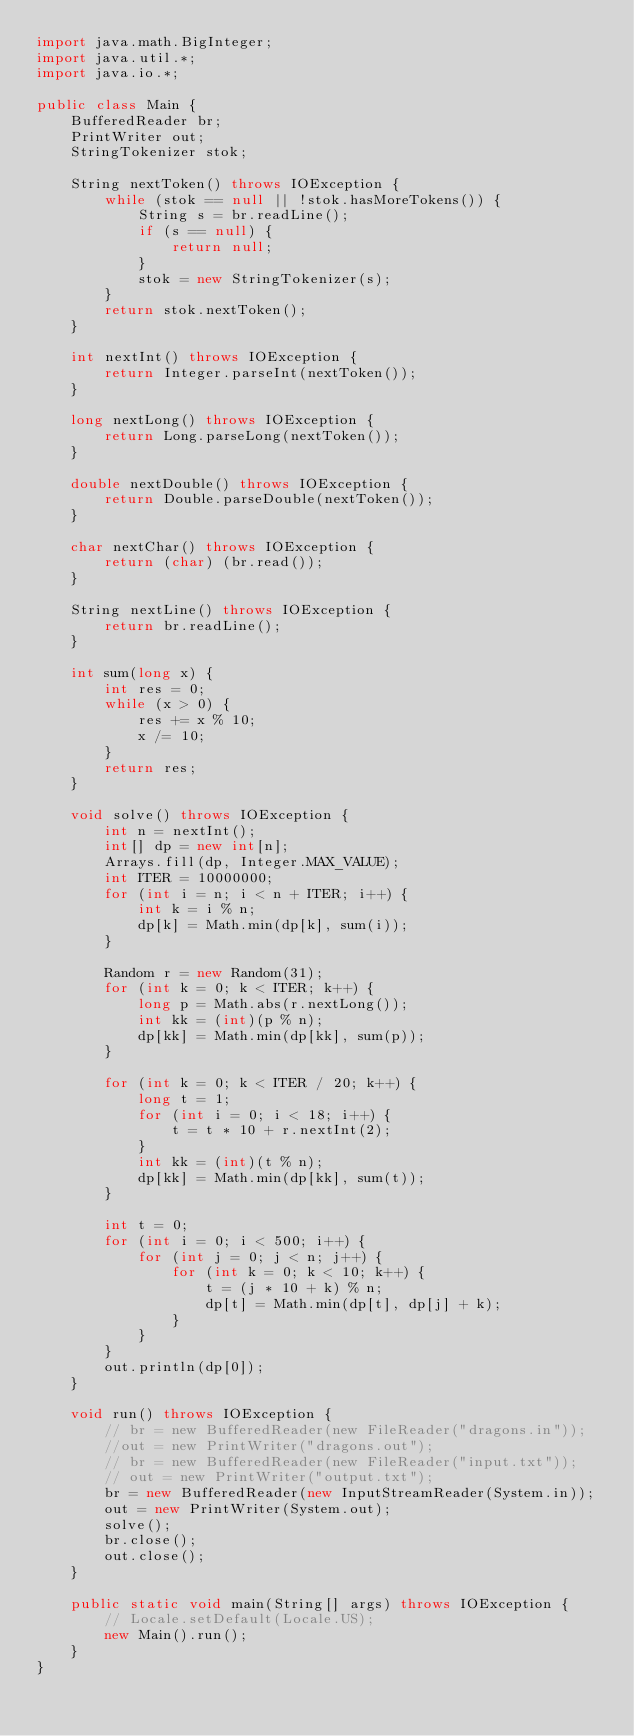<code> <loc_0><loc_0><loc_500><loc_500><_Java_>import java.math.BigInteger;
import java.util.*;
import java.io.*;

public class Main {
    BufferedReader br;
    PrintWriter out;
    StringTokenizer stok;

    String nextToken() throws IOException {
        while (stok == null || !stok.hasMoreTokens()) {
            String s = br.readLine();
            if (s == null) {
                return null;
            }
            stok = new StringTokenizer(s);
        }
        return stok.nextToken();
    }

    int nextInt() throws IOException {
        return Integer.parseInt(nextToken());
    }

    long nextLong() throws IOException {
        return Long.parseLong(nextToken());
    }

    double nextDouble() throws IOException {
        return Double.parseDouble(nextToken());
    }

    char nextChar() throws IOException {
        return (char) (br.read());
    }

    String nextLine() throws IOException {
        return br.readLine();
    }

    int sum(long x) {
        int res = 0;
        while (x > 0) {
            res += x % 10;
            x /= 10;
        }
        return res;
    }

    void solve() throws IOException {
        int n = nextInt();
        int[] dp = new int[n];
        Arrays.fill(dp, Integer.MAX_VALUE);
        int ITER = 10000000;
        for (int i = n; i < n + ITER; i++) {
            int k = i % n;
            dp[k] = Math.min(dp[k], sum(i));
        }

        Random r = new Random(31);
        for (int k = 0; k < ITER; k++) {
            long p = Math.abs(r.nextLong());
            int kk = (int)(p % n);
            dp[kk] = Math.min(dp[kk], sum(p));
        }

        for (int k = 0; k < ITER / 20; k++) {
            long t = 1;
            for (int i = 0; i < 18; i++) {
                t = t * 10 + r.nextInt(2);
            }
            int kk = (int)(t % n);
            dp[kk] = Math.min(dp[kk], sum(t));
        }

        int t = 0;
        for (int i = 0; i < 500; i++) {
            for (int j = 0; j < n; j++) {
                for (int k = 0; k < 10; k++) {
                    t = (j * 10 + k) % n;
                    dp[t] = Math.min(dp[t], dp[j] + k);
                }
            }
        }
        out.println(dp[0]);
    }

    void run() throws IOException {
        // br = new BufferedReader(new FileReader("dragons.in"));
        //out = new PrintWriter("dragons.out");
        // br = new BufferedReader(new FileReader("input.txt"));
        // out = new PrintWriter("output.txt");
        br = new BufferedReader(new InputStreamReader(System.in));
        out = new PrintWriter(System.out);
        solve();
        br.close();
        out.close();
    }

    public static void main(String[] args) throws IOException {
        // Locale.setDefault(Locale.US);
        new Main().run();
    }
}</code> 